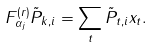Convert formula to latex. <formula><loc_0><loc_0><loc_500><loc_500>F _ { \alpha _ { j } } ^ { ( r ) } \tilde { P } _ { k , i } = \sum _ { t } \tilde { P } _ { t , i } x _ { t } .</formula> 